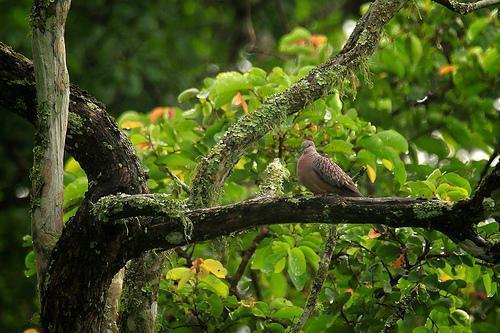How many birds are there?
Give a very brief answer. 1. How many individual branches are shown?
Give a very brief answer. 4. How many people are in the photo?
Give a very brief answer. 0. 